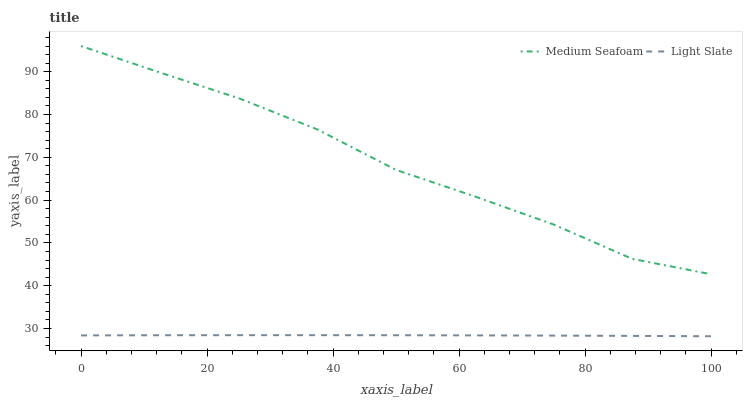Does Light Slate have the minimum area under the curve?
Answer yes or no. Yes. Does Medium Seafoam have the maximum area under the curve?
Answer yes or no. Yes. Does Medium Seafoam have the minimum area under the curve?
Answer yes or no. No. Is Light Slate the smoothest?
Answer yes or no. Yes. Is Medium Seafoam the roughest?
Answer yes or no. Yes. Is Medium Seafoam the smoothest?
Answer yes or no. No. Does Light Slate have the lowest value?
Answer yes or no. Yes. Does Medium Seafoam have the lowest value?
Answer yes or no. No. Does Medium Seafoam have the highest value?
Answer yes or no. Yes. Is Light Slate less than Medium Seafoam?
Answer yes or no. Yes. Is Medium Seafoam greater than Light Slate?
Answer yes or no. Yes. Does Light Slate intersect Medium Seafoam?
Answer yes or no. No. 